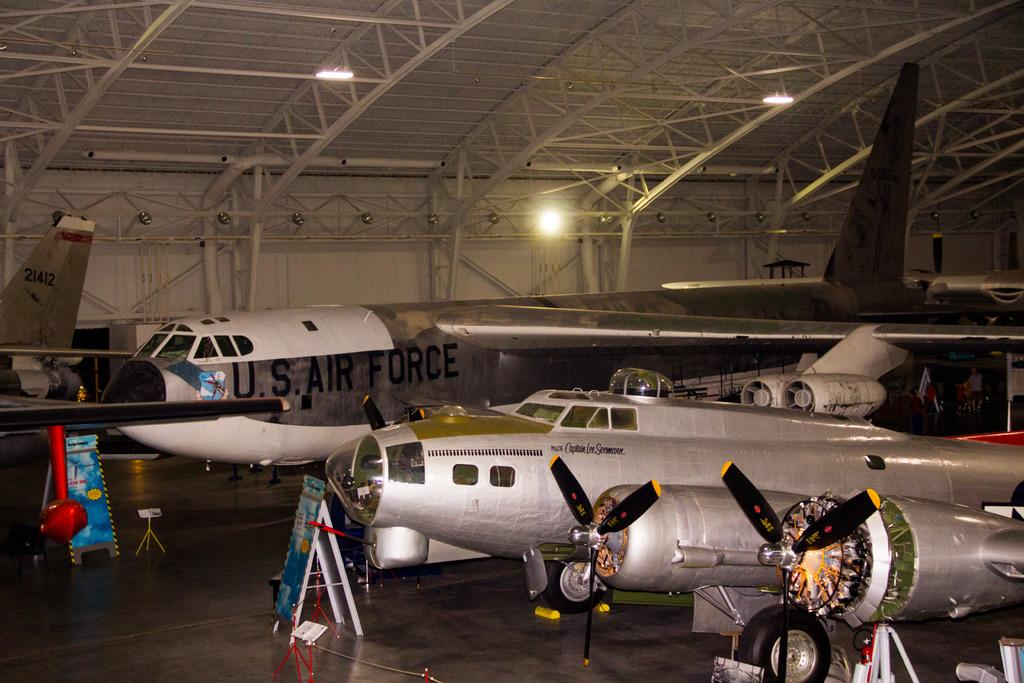<image>
Give a short and clear explanation of the subsequent image. A large U.S. Air Force jet sits in a hanger. 